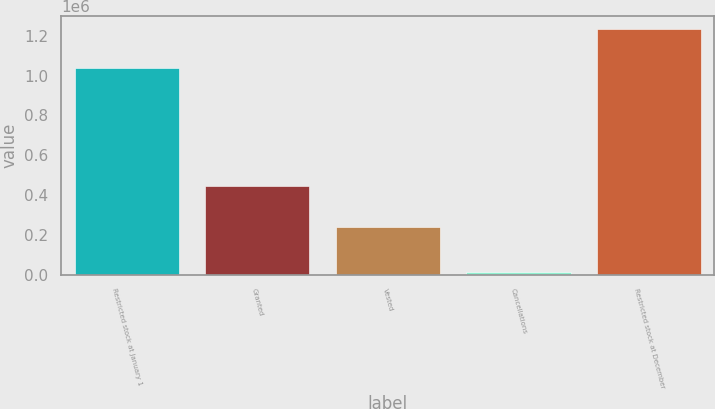<chart> <loc_0><loc_0><loc_500><loc_500><bar_chart><fcel>Restricted stock at January 1<fcel>Granted<fcel>Vested<fcel>Cancellations<fcel>Restricted stock at December<nl><fcel>1.03827e+06<fcel>444985<fcel>237370<fcel>10380<fcel>1.2355e+06<nl></chart> 